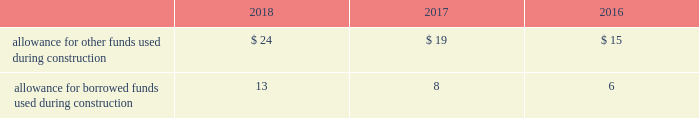Investment tax credits have been deferred by the regulated utility subsidiaries and are being amortized to income over the average estimated service lives of the related assets .
The company recognizes accrued interest and penalties related to tax positions as a component of income tax expense and accounts for sales tax collected from customers and remitted to taxing authorities on a net basis .
See note 14 2014income taxes for additional information .
Allowance for funds used during construction afudc is a non-cash credit to income with a corresponding charge to utility plant that represents the cost of borrowed funds or a return on equity funds devoted to plant under construction .
The regulated utility subsidiaries record afudc to the extent permitted by the pucs .
The portion of afudc attributable to borrowed funds is shown as a reduction of interest , net on the consolidated statements of operations .
Any portion of afudc attributable to equity funds would be included in other , net on the consolidated statements of operations .
Afudc is provided in the table for the years ended december 31: .
Environmental costs the company 2019s water and wastewater operations and the operations of its market-based businesses are subject to u.s .
Federal , state , local and foreign requirements relating to environmental protection , and as such , the company periodically becomes subject to environmental claims in the normal course of business .
Environmental expenditures that relate to current operations or provide a future benefit are expensed or capitalized as appropriate .
Remediation costs that relate to an existing condition caused by past operations are accrued , on an undiscounted basis , when it is probable that these costs will be incurred and can be reasonably estimated .
A conservation agreement entered into by a subsidiary of the company with the national oceanic and atmospheric administration in 2010 and amended in 2017 required the subsidiary to , among other provisions , implement certain measures to protect the steelhead trout and its habitat in the carmel river watershed in the state of california .
The subsidiary agreed to pay $ 1 million annually commencing in 2010 with the final payment being made in 2021 .
Remediation costs accrued amounted to $ 4 million and $ 6 million as of december 31 , 2018 and 2017 , respectively .
Derivative financial instruments the company uses derivative financial instruments for purposes of hedging exposures to fluctuations in interest rates .
These derivative contracts are entered into for periods consistent with the related underlying exposures and do not constitute positions independent of those exposures .
The company does not enter into derivative contracts for speculative purposes and does not use leveraged instruments .
All derivatives are recognized on the balance sheet at fair value .
On the date the derivative contract is entered into , the company may designate the derivative as a hedge of the fair value of a recognized asset or liability ( fair-value hedge ) or a hedge of a forecasted transaction or of the variability of cash flows to be received or paid related to a recognized asset or liability ( cash-flow hedge ) .
Changes in the fair value of a fair-value hedge , along with the gain or loss on the underlying hedged item , are recorded in current-period earnings .
The gains and losses on the effective portion of cash-flow hedges are recorded in other comprehensive income , until earnings are affected by the variability of cash flows .
Any ineffective portion of designated cash-flow hedges is recognized in current-period earnings. .
What was 2018 allowance for borrowed funds used during construction as a percentage of allowance for other funds used during construction? 
Computations: (13 / 24)
Answer: 0.54167. 